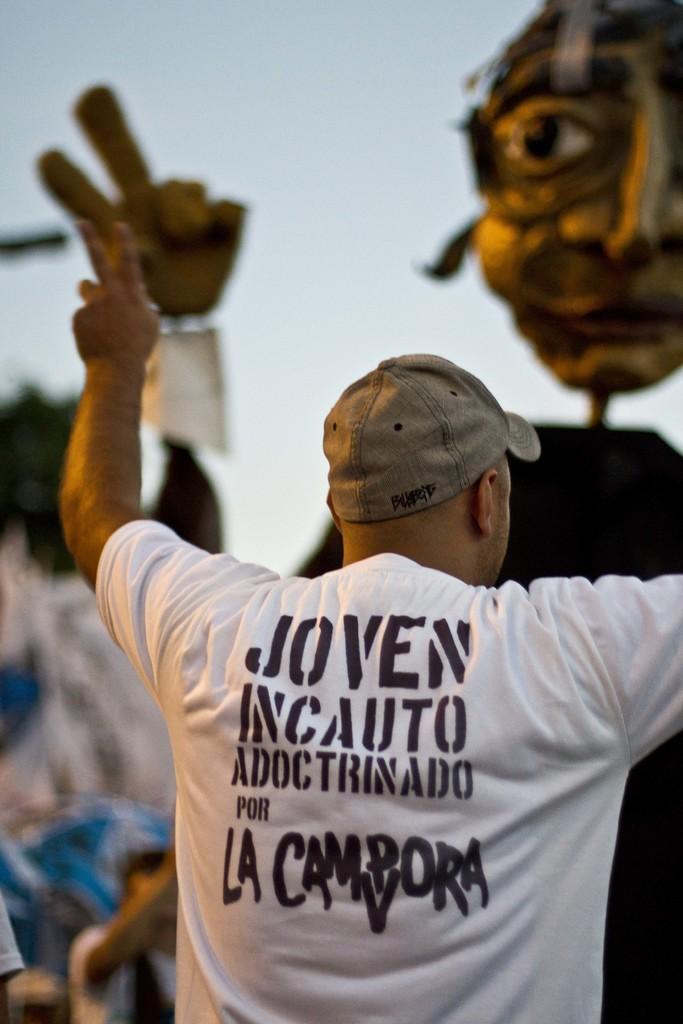Could you give a brief overview of what you see in this image? In the foreground of the picture there is a person wearing white t-shirt and cap. In the center it is blurred. In the background there is a mask. 